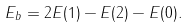<formula> <loc_0><loc_0><loc_500><loc_500>E _ { b } = 2 E ( 1 ) - E ( 2 ) - E ( 0 ) .</formula> 